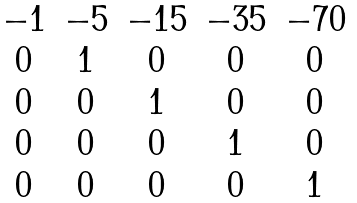<formula> <loc_0><loc_0><loc_500><loc_500>\begin{matrix} - 1 & - 5 & - 1 5 & - 3 5 & - 7 0 \\ 0 & 1 & 0 & 0 & 0 \\ 0 & 0 & 1 & 0 & 0 \\ 0 & 0 & 0 & 1 & 0 \\ 0 & 0 & 0 & 0 & 1 \end{matrix}</formula> 